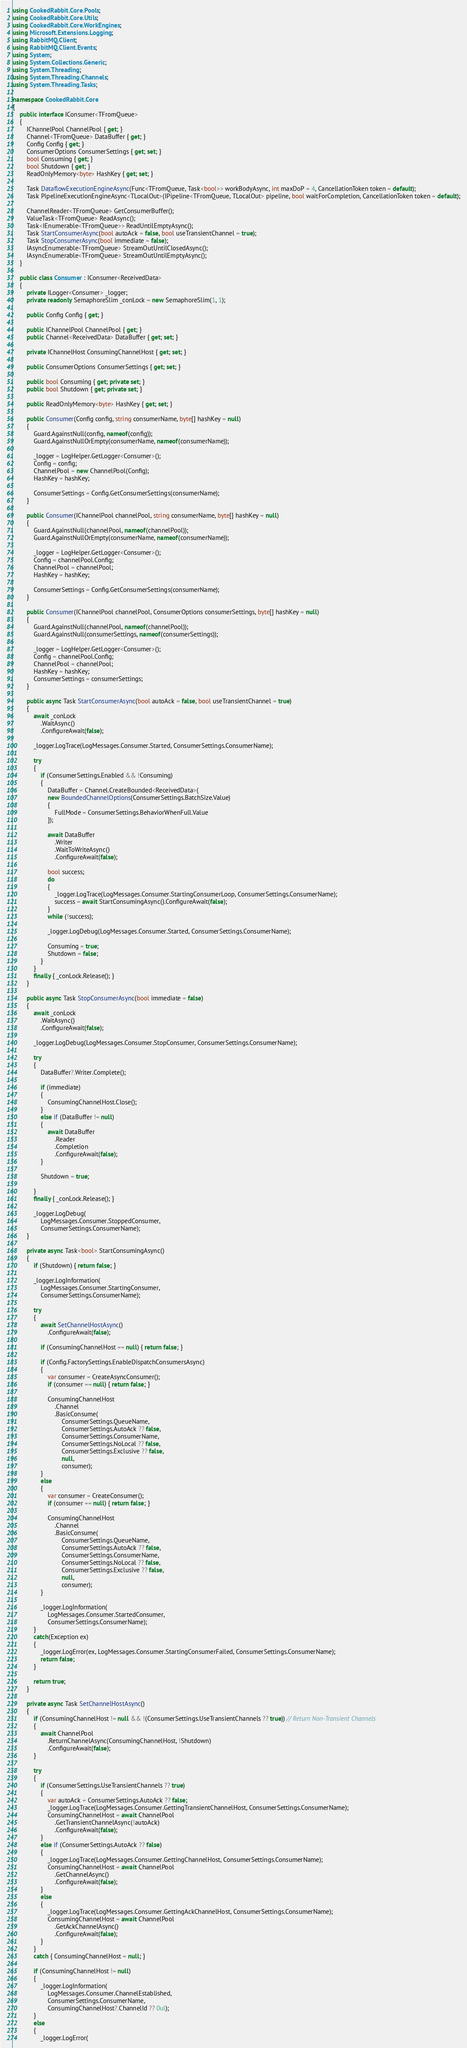Convert code to text. <code><loc_0><loc_0><loc_500><loc_500><_C#_>using CookedRabbit.Core.Pools;
using CookedRabbit.Core.Utils;
using CookedRabbit.Core.WorkEngines;
using Microsoft.Extensions.Logging;
using RabbitMQ.Client;
using RabbitMQ.Client.Events;
using System;
using System.Collections.Generic;
using System.Threading;
using System.Threading.Channels;
using System.Threading.Tasks;

namespace CookedRabbit.Core
{
    public interface IConsumer<TFromQueue>
    {
        IChannelPool ChannelPool { get; }
        Channel<TFromQueue> DataBuffer { get; }
        Config Config { get; }
        ConsumerOptions ConsumerSettings { get; set; }
        bool Consuming { get; }
        bool Shutdown { get; }
        ReadOnlyMemory<byte> HashKey { get; set; }

        Task DataflowExecutionEngineAsync(Func<TFromQueue, Task<bool>> workBodyAsync, int maxDoP = 4, CancellationToken token = default);
        Task PipelineExecutionEngineAsync<TLocalOut>(IPipeline<TFromQueue, TLocalOut> pipeline, bool waitForCompletion, CancellationToken token = default);

        ChannelReader<TFromQueue> GetConsumerBuffer();
        ValueTask<TFromQueue> ReadAsync();
        Task<IEnumerable<TFromQueue>> ReadUntilEmptyAsync();
        Task StartConsumerAsync(bool autoAck = false, bool useTransientChannel = true);
        Task StopConsumerAsync(bool immediate = false);
        IAsyncEnumerable<TFromQueue> StreamOutUntilClosedAsync();
        IAsyncEnumerable<TFromQueue> StreamOutUntilEmptyAsync();
    }

    public class Consumer : IConsumer<ReceivedData>
    {
        private ILogger<Consumer> _logger;
        private readonly SemaphoreSlim _conLock = new SemaphoreSlim(1, 1);

        public Config Config { get; }

        public IChannelPool ChannelPool { get; }
        public Channel<ReceivedData> DataBuffer { get; set; }

        private IChannelHost ConsumingChannelHost { get; set; }

        public ConsumerOptions ConsumerSettings { get; set; }

        public bool Consuming { get; private set; }
        public bool Shutdown { get; private set; }

        public ReadOnlyMemory<byte> HashKey { get; set; }

        public Consumer(Config config, string consumerName, byte[] hashKey = null)
        {
            Guard.AgainstNull(config, nameof(config));
            Guard.AgainstNullOrEmpty(consumerName, nameof(consumerName));

            _logger = LogHelper.GetLogger<Consumer>();
            Config = config;
            ChannelPool = new ChannelPool(Config);
            HashKey = hashKey;

            ConsumerSettings = Config.GetConsumerSettings(consumerName);
        }

        public Consumer(IChannelPool channelPool, string consumerName, byte[] hashKey = null)
        {
            Guard.AgainstNull(channelPool, nameof(channelPool));
            Guard.AgainstNullOrEmpty(consumerName, nameof(consumerName));

            _logger = LogHelper.GetLogger<Consumer>();
            Config = channelPool.Config;
            ChannelPool = channelPool;
            HashKey = hashKey;

            ConsumerSettings = Config.GetConsumerSettings(consumerName);
        }

        public Consumer(IChannelPool channelPool, ConsumerOptions consumerSettings, byte[] hashKey = null)
        {
            Guard.AgainstNull(channelPool, nameof(channelPool));
            Guard.AgainstNull(consumerSettings, nameof(consumerSettings));

            _logger = LogHelper.GetLogger<Consumer>();
            Config = channelPool.Config;
            ChannelPool = channelPool;
            HashKey = hashKey;
            ConsumerSettings = consumerSettings;
        }

        public async Task StartConsumerAsync(bool autoAck = false, bool useTransientChannel = true)
        {
            await _conLock
                .WaitAsync()
                .ConfigureAwait(false);

            _logger.LogTrace(LogMessages.Consumer.Started, ConsumerSettings.ConsumerName);

            try
            {
                if (ConsumerSettings.Enabled && !Consuming)
                {
                    DataBuffer = Channel.CreateBounded<ReceivedData>(
                    new BoundedChannelOptions(ConsumerSettings.BatchSize.Value)
                    {
                        FullMode = ConsumerSettings.BehaviorWhenFull.Value
                    });

                    await DataBuffer
                        .Writer
                        .WaitToWriteAsync()
                        .ConfigureAwait(false);

                    bool success;
                    do
                    {
                        _logger.LogTrace(LogMessages.Consumer.StartingConsumerLoop, ConsumerSettings.ConsumerName);
                        success = await StartConsumingAsync().ConfigureAwait(false);
                    }
                    while (!success);

                    _logger.LogDebug(LogMessages.Consumer.Started, ConsumerSettings.ConsumerName);

                    Consuming = true;
                    Shutdown = false;
                }
            }
            finally { _conLock.Release(); }
        }

        public async Task StopConsumerAsync(bool immediate = false)
        {
            await _conLock
                .WaitAsync()
                .ConfigureAwait(false);

            _logger.LogDebug(LogMessages.Consumer.StopConsumer, ConsumerSettings.ConsumerName);

            try
            {
                DataBuffer?.Writer.Complete();

                if (immediate)
                {
                    ConsumingChannelHost.Close();
                }
                else if (DataBuffer != null)
                {
                    await DataBuffer
                        .Reader
                        .Completion
                        .ConfigureAwait(false);
                }

                Shutdown = true;

            }
            finally { _conLock.Release(); }

            _logger.LogDebug(
                LogMessages.Consumer.StoppedConsumer,
                ConsumerSettings.ConsumerName);
        }

        private async Task<bool> StartConsumingAsync()
        {
            if (Shutdown) { return false; }

            _logger.LogInformation(
                LogMessages.Consumer.StartingConsumer,
                ConsumerSettings.ConsumerName);

            try
            {
                await SetChannelHostAsync()
                    .ConfigureAwait(false);

                if (ConsumingChannelHost == null) { return false; }

                if (Config.FactorySettings.EnableDispatchConsumersAsync)
                {
                    var consumer = CreateAsyncConsumer();
                    if (consumer == null) { return false; }

                    ConsumingChannelHost
                        .Channel
                        .BasicConsume(
                            ConsumerSettings.QueueName,
                            ConsumerSettings.AutoAck ?? false,
                            ConsumerSettings.ConsumerName,
                            ConsumerSettings.NoLocal ?? false,
                            ConsumerSettings.Exclusive ?? false,
                            null,
                            consumer);
                }
                else
                {
                    var consumer = CreateConsumer();
                    if (consumer == null) { return false; }

                    ConsumingChannelHost
                        .Channel
                        .BasicConsume(
                            ConsumerSettings.QueueName,
                            ConsumerSettings.AutoAck ?? false,
                            ConsumerSettings.ConsumerName,
                            ConsumerSettings.NoLocal ?? false,
                            ConsumerSettings.Exclusive ?? false,
                            null,
                            consumer);
                }

                _logger.LogInformation(
                    LogMessages.Consumer.StartedConsumer,
                    ConsumerSettings.ConsumerName);
            }
            catch(Exception ex)
            {
                _logger.LogError(ex, LogMessages.Consumer.StartingConsumerFailed, ConsumerSettings.ConsumerName);
                return false;
            }

            return true;
        }

        private async Task SetChannelHostAsync()
        {
            if (ConsumingChannelHost != null && !(ConsumerSettings.UseTransientChannels ?? true)) // Return Non-Transient Channels
            {
                await ChannelPool
                    .ReturnChannelAsync(ConsumingChannelHost, !Shutdown)
                    .ConfigureAwait(false);
            }

            try
            {
                if (ConsumerSettings.UseTransientChannels ?? true)
                {
                    var autoAck = ConsumerSettings.AutoAck ?? false;
                    _logger.LogTrace(LogMessages.Consumer.GettingTransientChannelHost, ConsumerSettings.ConsumerName);
                    ConsumingChannelHost = await ChannelPool
                        .GetTransientChannelAsync(!autoAck)
                        .ConfigureAwait(false);
                }
                else if (ConsumerSettings.AutoAck ?? false)
                {
                    _logger.LogTrace(LogMessages.Consumer.GettingChannelHost, ConsumerSettings.ConsumerName);
                    ConsumingChannelHost = await ChannelPool
                        .GetChannelAsync()
                        .ConfigureAwait(false);
                }
                else
                {
                    _logger.LogTrace(LogMessages.Consumer.GettingAckChannelHost, ConsumerSettings.ConsumerName);
                    ConsumingChannelHost = await ChannelPool
                        .GetAckChannelAsync()
                        .ConfigureAwait(false);
                }
            }
            catch { ConsumingChannelHost = null; }

            if (ConsumingChannelHost != null)
            {
                _logger.LogInformation(
                    LogMessages.Consumer.ChannelEstablished,
                    ConsumerSettings.ConsumerName,
                    ConsumingChannelHost?.ChannelId ?? 0ul);
            }
            else
            {
                _logger.LogError(</code> 